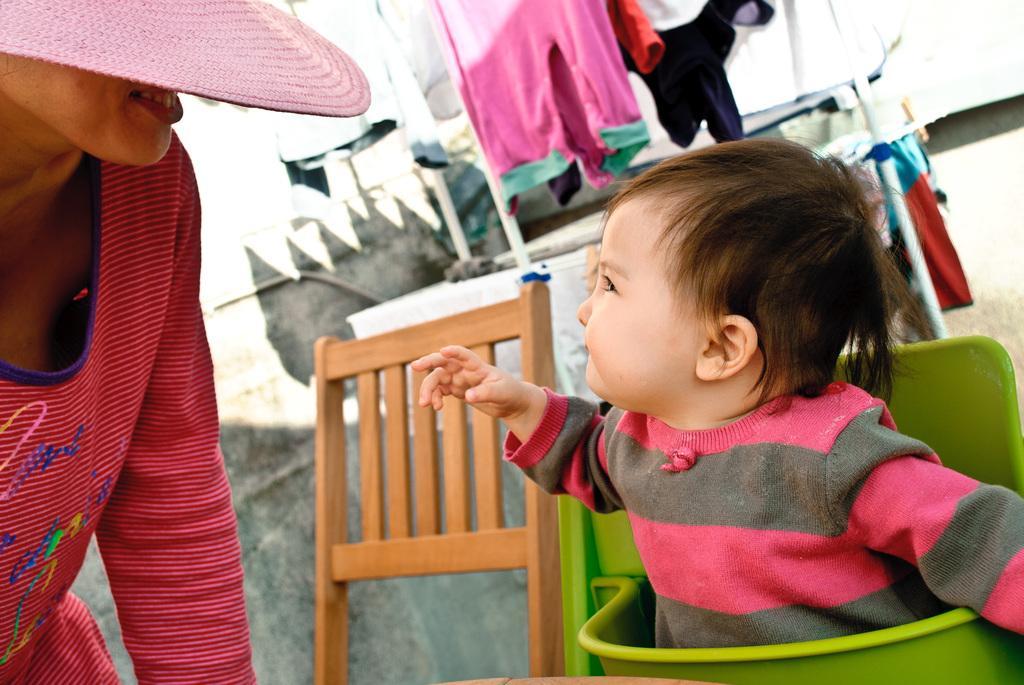Describe this image in one or two sentences. Here we can see a kid, chair, and a person. In the background we can see clothes. 